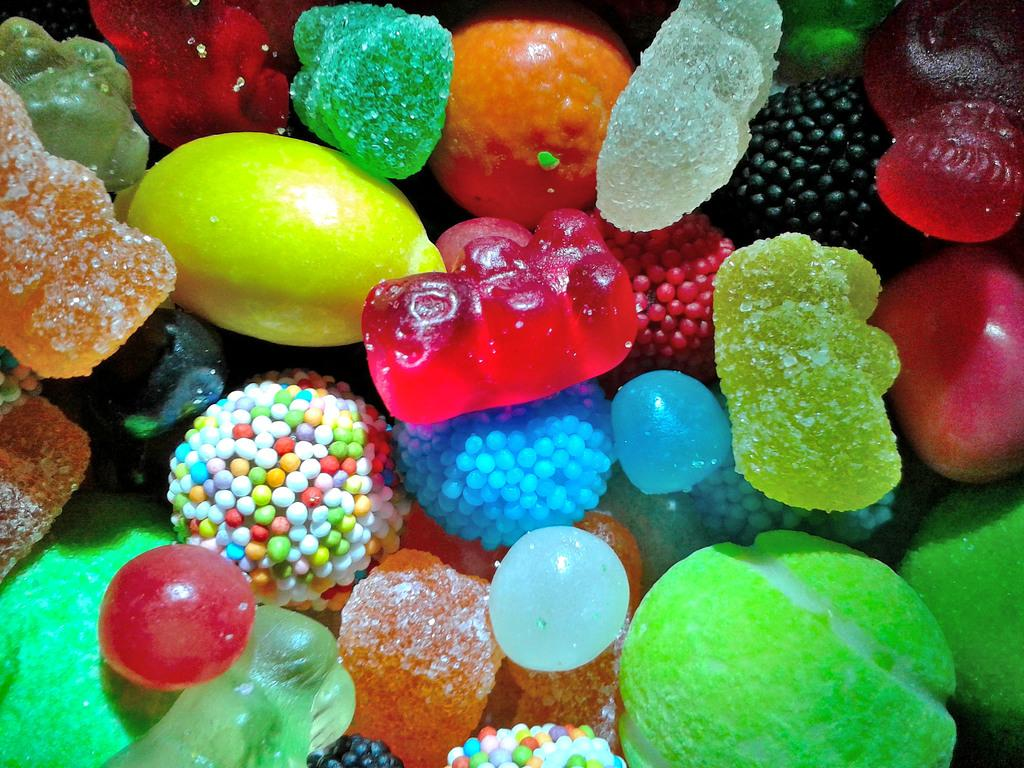What types of sweets can be seen in the image? There are different types of jellies and candies in the image. Can you describe the appearance of the jellies in the image? The different types of jellies in the image have various colors and shapes. What type of bird can be seen flying in the image? There are no birds present in the image; it only features jellies and candies. 